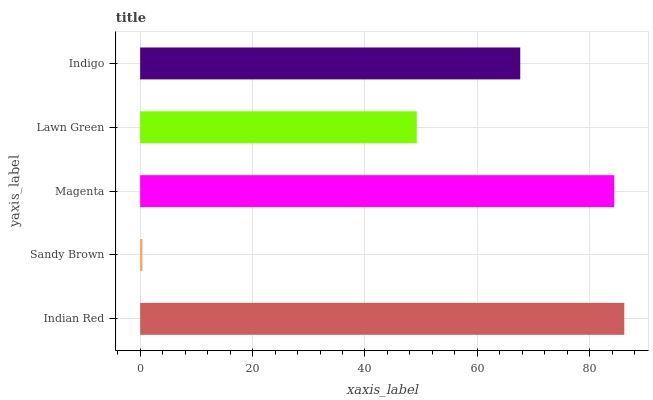Is Sandy Brown the minimum?
Answer yes or no. Yes. Is Indian Red the maximum?
Answer yes or no. Yes. Is Magenta the minimum?
Answer yes or no. No. Is Magenta the maximum?
Answer yes or no. No. Is Magenta greater than Sandy Brown?
Answer yes or no. Yes. Is Sandy Brown less than Magenta?
Answer yes or no. Yes. Is Sandy Brown greater than Magenta?
Answer yes or no. No. Is Magenta less than Sandy Brown?
Answer yes or no. No. Is Indigo the high median?
Answer yes or no. Yes. Is Indigo the low median?
Answer yes or no. Yes. Is Lawn Green the high median?
Answer yes or no. No. Is Indian Red the low median?
Answer yes or no. No. 